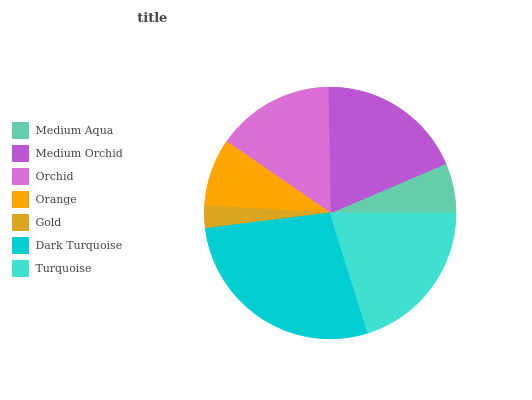Is Gold the minimum?
Answer yes or no. Yes. Is Dark Turquoise the maximum?
Answer yes or no. Yes. Is Medium Orchid the minimum?
Answer yes or no. No. Is Medium Orchid the maximum?
Answer yes or no. No. Is Medium Orchid greater than Medium Aqua?
Answer yes or no. Yes. Is Medium Aqua less than Medium Orchid?
Answer yes or no. Yes. Is Medium Aqua greater than Medium Orchid?
Answer yes or no. No. Is Medium Orchid less than Medium Aqua?
Answer yes or no. No. Is Orchid the high median?
Answer yes or no. Yes. Is Orchid the low median?
Answer yes or no. Yes. Is Dark Turquoise the high median?
Answer yes or no. No. Is Medium Orchid the low median?
Answer yes or no. No. 